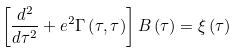Convert formula to latex. <formula><loc_0><loc_0><loc_500><loc_500>\left [ \frac { d ^ { 2 } } { d \tau ^ { 2 } } + e ^ { 2 } \Gamma \left ( \tau , \tau \right ) \right ] B \left ( \tau \right ) = \xi \left ( \tau \right )</formula> 